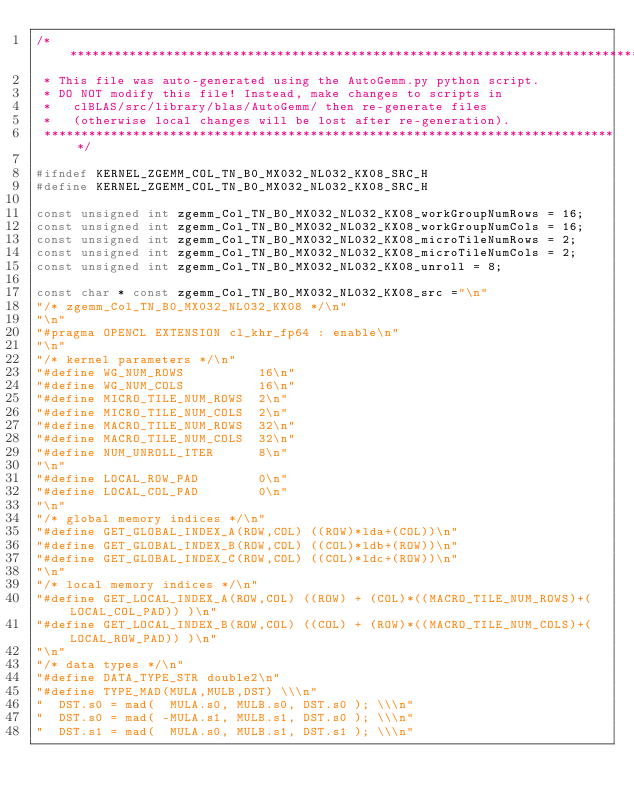<code> <loc_0><loc_0><loc_500><loc_500><_C++_>/*******************************************************************************
 * This file was auto-generated using the AutoGemm.py python script.
 * DO NOT modify this file! Instead, make changes to scripts in
 *   clBLAS/src/library/blas/AutoGemm/ then re-generate files
 *   (otherwise local changes will be lost after re-generation).
 ******************************************************************************/

#ifndef KERNEL_ZGEMM_COL_TN_B0_MX032_NL032_KX08_SRC_H
#define KERNEL_ZGEMM_COL_TN_B0_MX032_NL032_KX08_SRC_H

const unsigned int zgemm_Col_TN_B0_MX032_NL032_KX08_workGroupNumRows = 16;
const unsigned int zgemm_Col_TN_B0_MX032_NL032_KX08_workGroupNumCols = 16;
const unsigned int zgemm_Col_TN_B0_MX032_NL032_KX08_microTileNumRows = 2;
const unsigned int zgemm_Col_TN_B0_MX032_NL032_KX08_microTileNumCols = 2;
const unsigned int zgemm_Col_TN_B0_MX032_NL032_KX08_unroll = 8;

const char * const zgemm_Col_TN_B0_MX032_NL032_KX08_src ="\n"
"/* zgemm_Col_TN_B0_MX032_NL032_KX08 */\n"
"\n"
"#pragma OPENCL EXTENSION cl_khr_fp64 : enable\n"
"\n"
"/* kernel parameters */\n"
"#define WG_NUM_ROWS          16\n"
"#define WG_NUM_COLS          16\n"
"#define MICRO_TILE_NUM_ROWS  2\n"
"#define MICRO_TILE_NUM_COLS  2\n"
"#define MACRO_TILE_NUM_ROWS  32\n"
"#define MACRO_TILE_NUM_COLS  32\n"
"#define NUM_UNROLL_ITER      8\n"
"\n"
"#define LOCAL_ROW_PAD        0\n"
"#define LOCAL_COL_PAD        0\n"
"\n"
"/* global memory indices */\n"
"#define GET_GLOBAL_INDEX_A(ROW,COL) ((ROW)*lda+(COL))\n"
"#define GET_GLOBAL_INDEX_B(ROW,COL) ((COL)*ldb+(ROW))\n"
"#define GET_GLOBAL_INDEX_C(ROW,COL) ((COL)*ldc+(ROW))\n"
"\n"
"/* local memory indices */\n"
"#define GET_LOCAL_INDEX_A(ROW,COL) ((ROW) + (COL)*((MACRO_TILE_NUM_ROWS)+(LOCAL_COL_PAD)) )\n"
"#define GET_LOCAL_INDEX_B(ROW,COL) ((COL) + (ROW)*((MACRO_TILE_NUM_COLS)+(LOCAL_ROW_PAD)) )\n"
"\n"
"/* data types */\n"
"#define DATA_TYPE_STR double2\n"
"#define TYPE_MAD(MULA,MULB,DST) \\\n"
"  DST.s0 = mad(  MULA.s0, MULB.s0, DST.s0 ); \\\n"
"  DST.s0 = mad( -MULA.s1, MULB.s1, DST.s0 ); \\\n"
"  DST.s1 = mad(  MULA.s0, MULB.s1, DST.s1 ); \\\n"</code> 